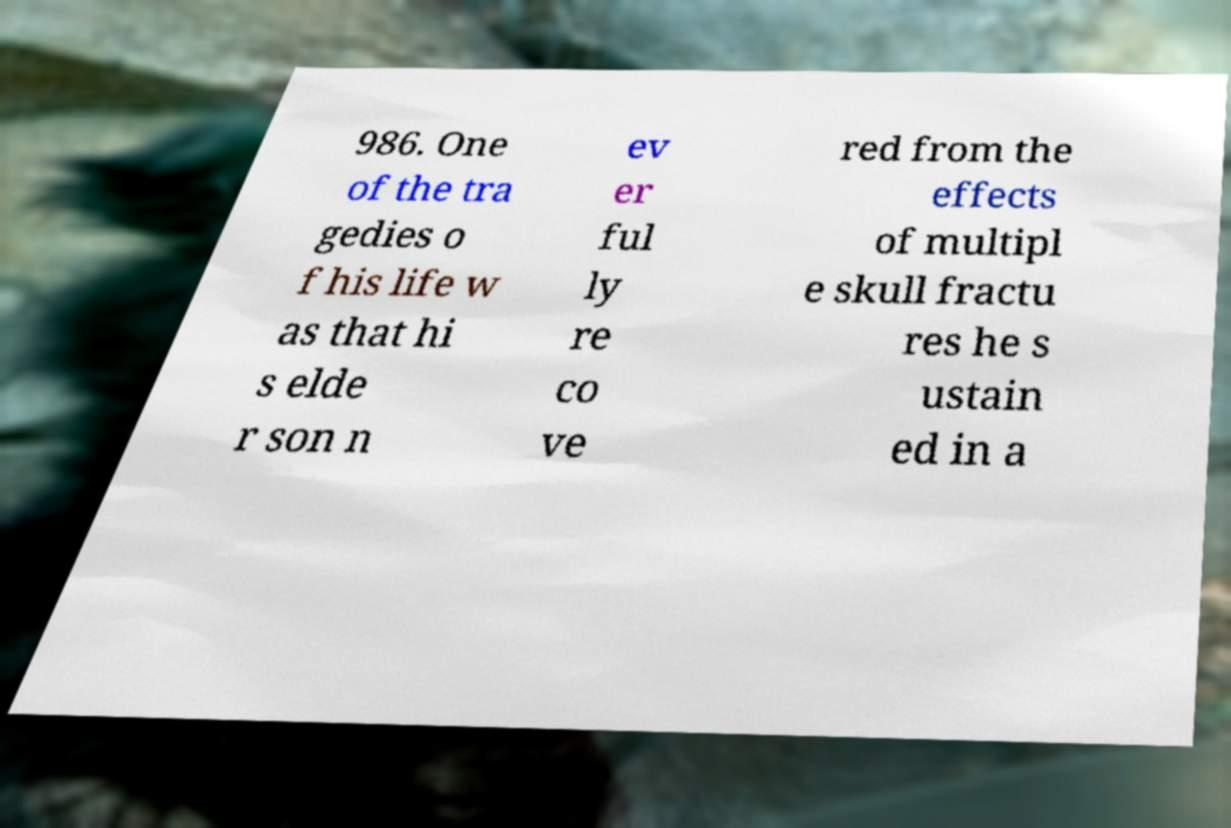Can you read and provide the text displayed in the image?This photo seems to have some interesting text. Can you extract and type it out for me? 986. One of the tra gedies o f his life w as that hi s elde r son n ev er ful ly re co ve red from the effects of multipl e skull fractu res he s ustain ed in a 